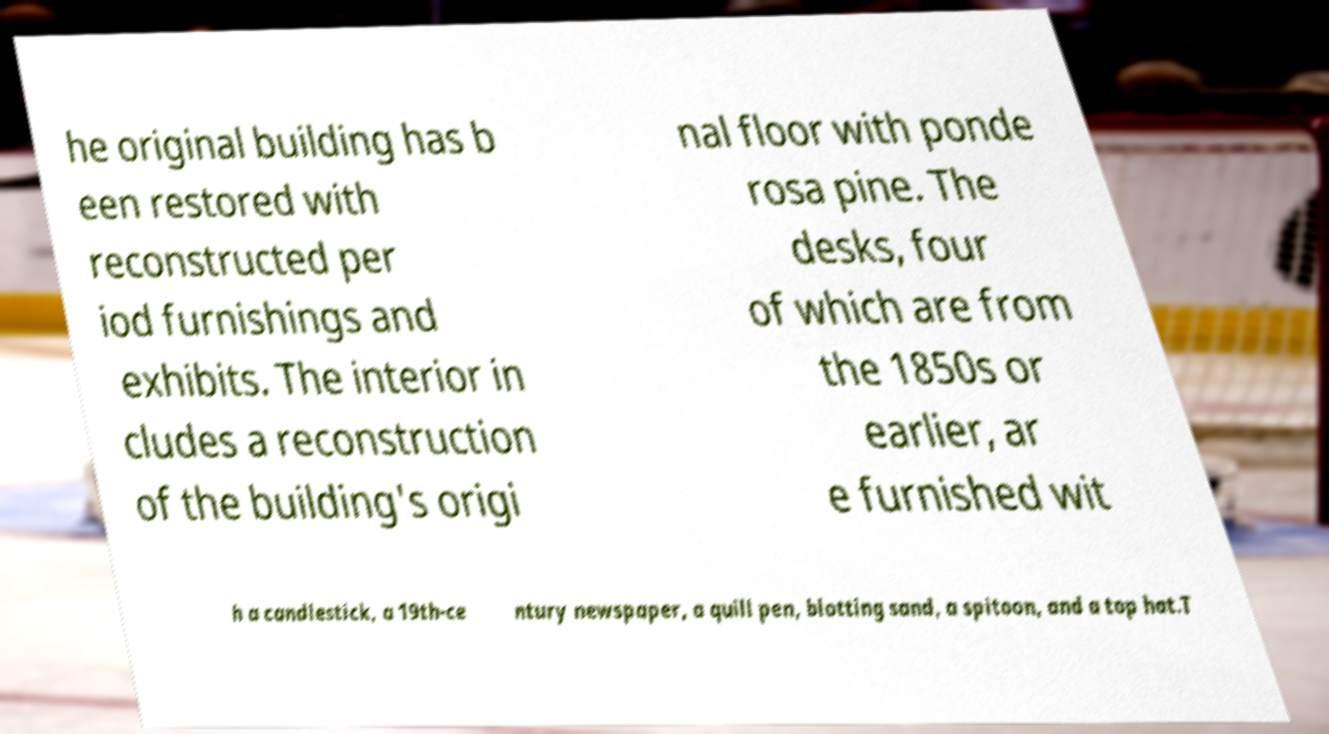Please identify and transcribe the text found in this image. he original building has b een restored with reconstructed per iod furnishings and exhibits. The interior in cludes a reconstruction of the building's origi nal floor with ponde rosa pine. The desks, four of which are from the 1850s or earlier, ar e furnished wit h a candlestick, a 19th-ce ntury newspaper, a quill pen, blotting sand, a spitoon, and a top hat.T 